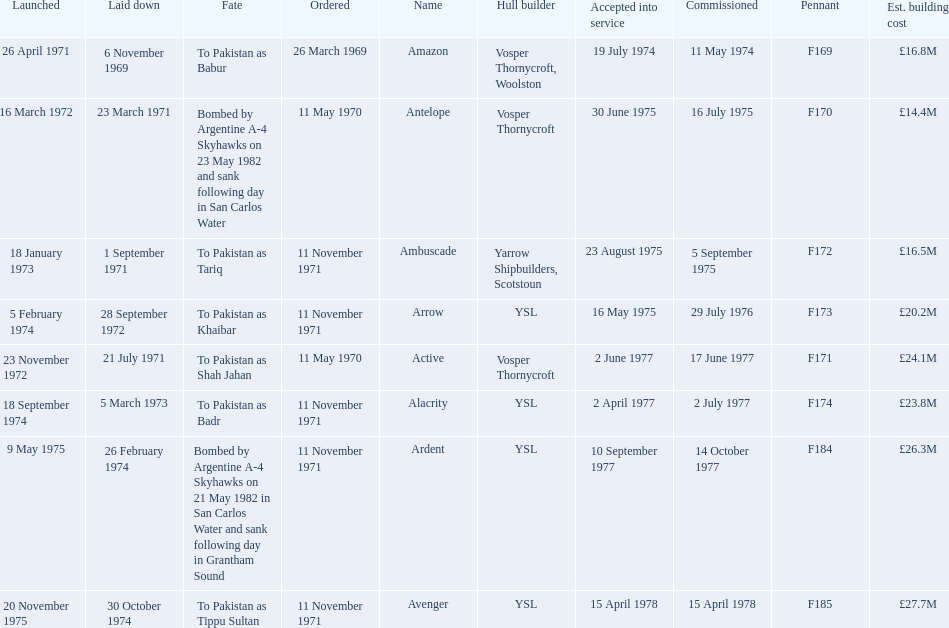Which ship had the highest estimated cost to build? Avenger. 